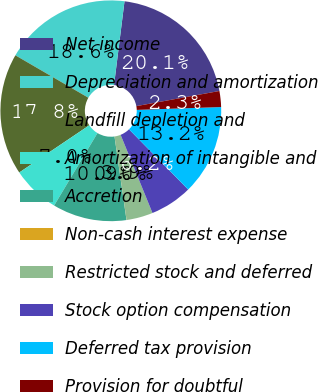Convert chart. <chart><loc_0><loc_0><loc_500><loc_500><pie_chart><fcel>Net income<fcel>Depreciation and amortization<fcel>Landfill depletion and<fcel>Amortization of intangible and<fcel>Accretion<fcel>Non-cash interest expense<fcel>Restricted stock and deferred<fcel>Stock option compensation<fcel>Deferred tax provision<fcel>Provision for doubtful<nl><fcel>20.15%<fcel>18.6%<fcel>17.82%<fcel>6.98%<fcel>10.85%<fcel>0.01%<fcel>3.88%<fcel>6.2%<fcel>13.18%<fcel>2.33%<nl></chart> 